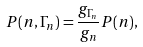<formula> <loc_0><loc_0><loc_500><loc_500>P ( n , \Gamma _ { n } ) = \frac { g _ { \Gamma _ { n } } } { g _ { n } } P ( n ) ,</formula> 